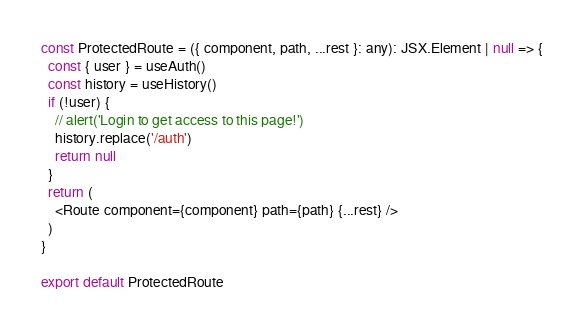Convert code to text. <code><loc_0><loc_0><loc_500><loc_500><_TypeScript_>
const ProtectedRoute = ({ component, path, ...rest }: any): JSX.Element | null => {
  const { user } = useAuth()
  const history = useHistory()
  if (!user) {
    // alert('Login to get access to this page!')
    history.replace('/auth')
    return null
  }
  return (
    <Route component={component} path={path} {...rest} />
  )
}

export default ProtectedRoute
</code> 